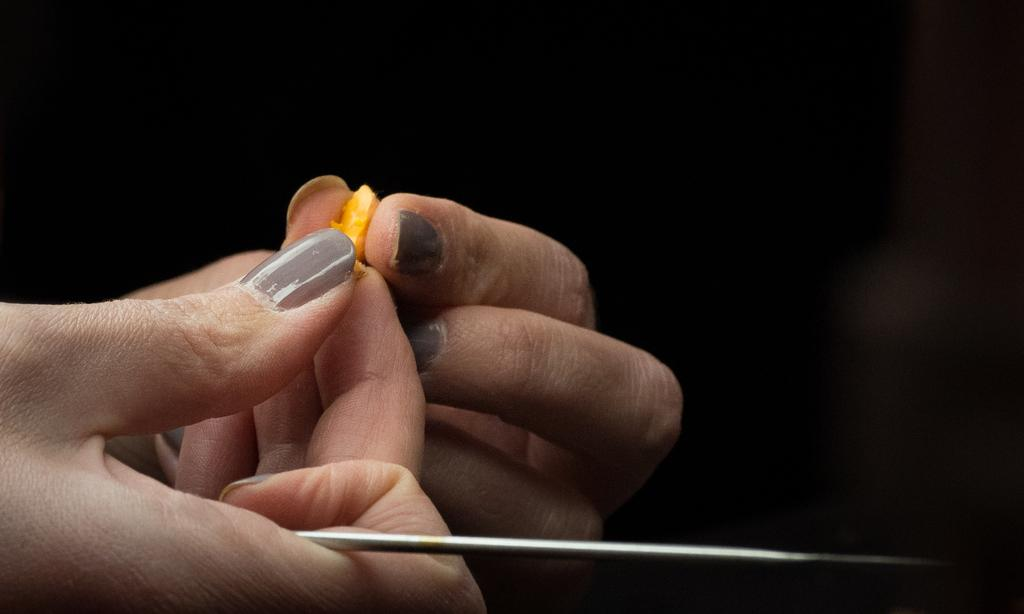What is happening in the image? There are hands holding objects in the image. Can you describe the objects being held? The objects are grey and orange in color. What can be seen in the background of the image? The background of the image is dark. What type of cherries are being picked in the image? There are no cherries present in the image; the objects being held are grey and orange. What hobbies are the people in the image engaged in? The image does not show any people, only hands holding objects. 